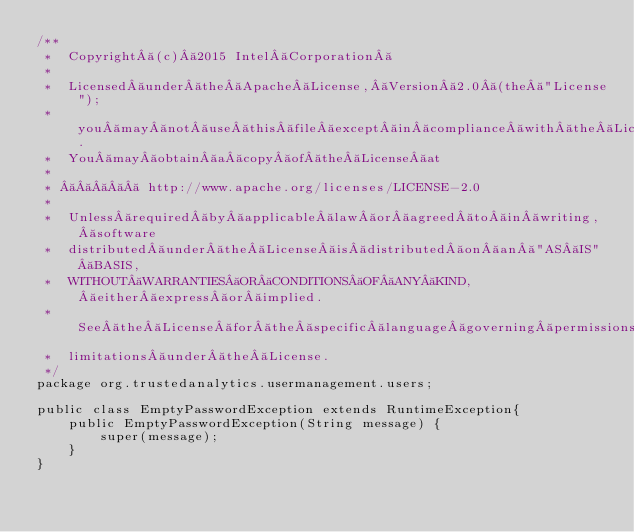Convert code to text. <code><loc_0><loc_0><loc_500><loc_500><_Java_>/**
 *  Copyright (c) 2015 Intel Corporation 
 *
 *  Licensed under the Apache License, Version 2.0 (the "License");
 *  you may not use this file except in compliance with the License.
 *  You may obtain a copy of the License at
 *
 *       http://www.apache.org/licenses/LICENSE-2.0
 *
 *  Unless required by applicable law or agreed to in writing, software
 *  distributed under the License is distributed on an "AS IS" BASIS,
 *  WITHOUT WARRANTIES OR CONDITIONS OF ANY KIND, either express or implied.
 *  See the License for the specific language governing permissions and
 *  limitations under the License.
 */
package org.trustedanalytics.usermanagement.users;

public class EmptyPasswordException extends RuntimeException{
    public EmptyPasswordException(String message) {
        super(message);
    }
}
</code> 